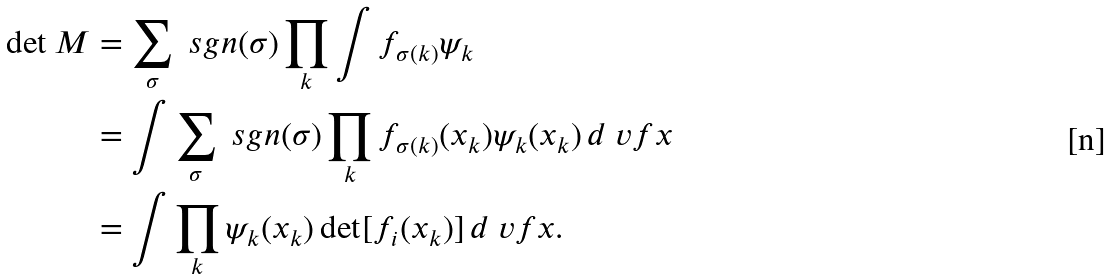<formula> <loc_0><loc_0><loc_500><loc_500>\det M & = \sum _ { \sigma } \ s g n ( \sigma ) \prod _ { k } \int f _ { \sigma ( k ) } \psi _ { k } \\ & = \int \sum _ { \sigma } \ s g n ( \sigma ) \prod _ { k } f _ { \sigma ( k ) } ( x _ { k } ) \psi _ { k } ( x _ { k } ) \, d \ v f x \\ & = \int \prod _ { k } \psi _ { k } ( x _ { k } ) \det [ f _ { i } ( x _ { k } ) ] \, d \ v f x .</formula> 